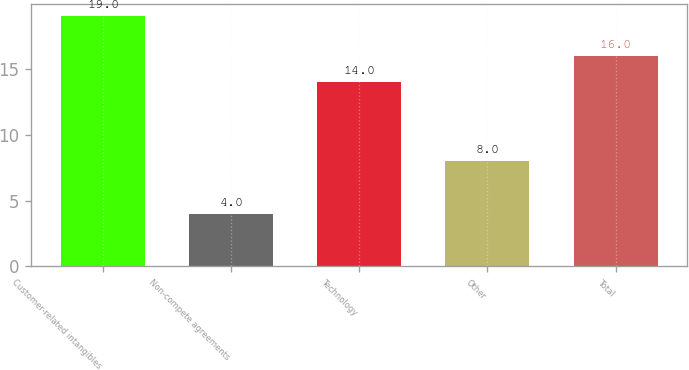Convert chart. <chart><loc_0><loc_0><loc_500><loc_500><bar_chart><fcel>Customer-related intangibles<fcel>Non-compete agreements<fcel>Technology<fcel>Other<fcel>Total<nl><fcel>19<fcel>4<fcel>14<fcel>8<fcel>16<nl></chart> 